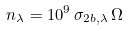Convert formula to latex. <formula><loc_0><loc_0><loc_500><loc_500>n _ { \lambda } = 1 0 ^ { 9 } \, \sigma _ { 2 b , \lambda } \, \Omega</formula> 